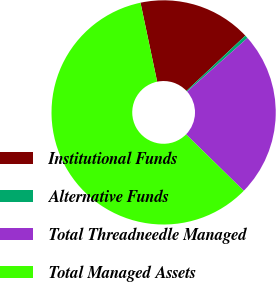Convert chart to OTSL. <chart><loc_0><loc_0><loc_500><loc_500><pie_chart><fcel>Institutional Funds<fcel>Alternative Funds<fcel>Total Threadneedle Managed<fcel>Total Managed Assets<nl><fcel>16.3%<fcel>0.46%<fcel>23.87%<fcel>59.36%<nl></chart> 